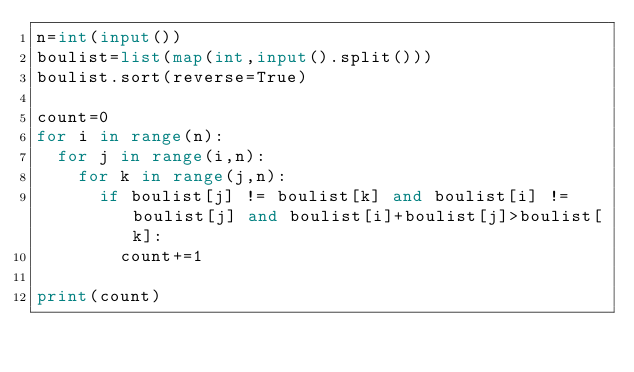<code> <loc_0><loc_0><loc_500><loc_500><_Python_>n=int(input())
boulist=list(map(int,input().split()))
boulist.sort(reverse=True)

count=0
for i in range(n):
  for j in range(i,n):
    for k in range(j,n):
      if boulist[j] != boulist[k] and boulist[i] != boulist[j] and boulist[i]+boulist[j]>boulist[k]:
        count+=1

print(count)


</code> 